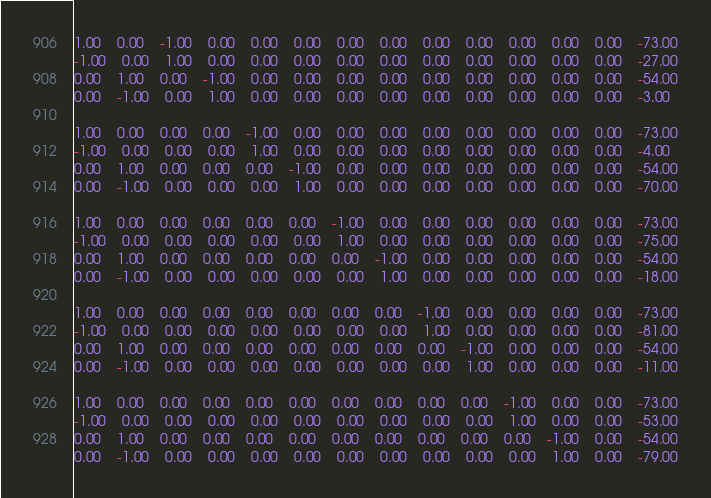<code> <loc_0><loc_0><loc_500><loc_500><_Matlab_>1.00	0.00	-1.00	0.00	0.00	0.00	0.00	0.00	0.00	0.00	0.00	0.00	0.00	-73.00
-1.00	0.00	1.00	0.00	0.00	0.00	0.00	0.00	0.00	0.00	0.00	0.00	0.00	-27.00
0.00	1.00	0.00	-1.00	0.00	0.00	0.00	0.00	0.00	0.00	0.00	0.00	0.00	-54.00
0.00	-1.00	0.00	1.00	0.00	0.00	0.00	0.00	0.00	0.00	0.00	0.00	0.00	-3.00

1.00	0.00	0.00	0.00	-1.00	0.00	0.00	0.00	0.00	0.00	0.00	0.00	0.00	-73.00
-1.00	0.00	0.00	0.00	1.00	0.00	0.00	0.00	0.00	0.00	0.00	0.00	0.00	-4.00
0.00	1.00	0.00	0.00	0.00	-1.00	0.00	0.00	0.00	0.00	0.00	0.00	0.00	-54.00
0.00	-1.00	0.00	0.00	0.00	1.00	0.00	0.00	0.00	0.00	0.00	0.00	0.00	-70.00

1.00	0.00	0.00	0.00	0.00	0.00	-1.00	0.00	0.00	0.00	0.00	0.00	0.00	-73.00
-1.00	0.00	0.00	0.00	0.00	0.00	1.00	0.00	0.00	0.00	0.00	0.00	0.00	-75.00
0.00	1.00	0.00	0.00	0.00	0.00	0.00	-1.00	0.00	0.00	0.00	0.00	0.00	-54.00
0.00	-1.00	0.00	0.00	0.00	0.00	0.00	1.00	0.00	0.00	0.00	0.00	0.00	-18.00

1.00	0.00	0.00	0.00	0.00	0.00	0.00	0.00	-1.00	0.00	0.00	0.00	0.00	-73.00
-1.00	0.00	0.00	0.00	0.00	0.00	0.00	0.00	1.00	0.00	0.00	0.00	0.00	-81.00
0.00	1.00	0.00	0.00	0.00	0.00	0.00	0.00	0.00	-1.00	0.00	0.00	0.00	-54.00
0.00	-1.00	0.00	0.00	0.00	0.00	0.00	0.00	0.00	1.00	0.00	0.00	0.00	-11.00

1.00	0.00	0.00	0.00	0.00	0.00	0.00	0.00	0.00	0.00	-1.00	0.00	0.00	-73.00
-1.00	0.00	0.00	0.00	0.00	0.00	0.00	0.00	0.00	0.00	1.00	0.00	0.00	-53.00
0.00	1.00	0.00	0.00	0.00	0.00	0.00	0.00	0.00	0.00	0.00	-1.00	0.00	-54.00
0.00	-1.00	0.00	0.00	0.00	0.00	0.00	0.00	0.00	0.00	0.00	1.00	0.00	-79.00
</code> 